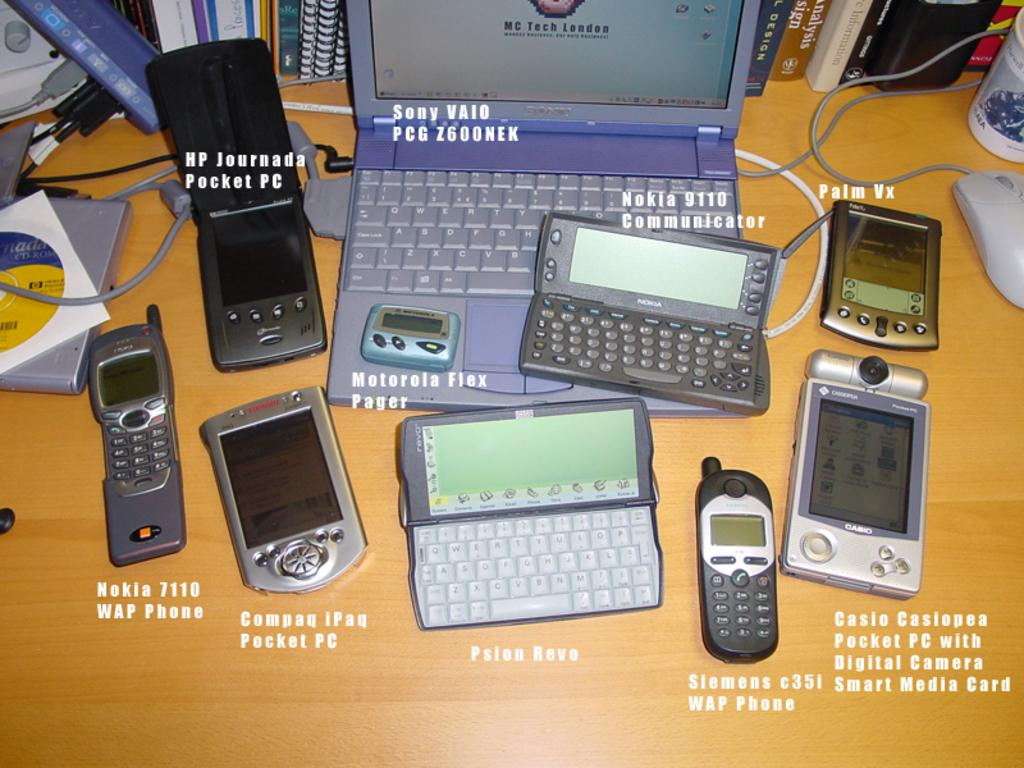<image>
Render a clear and concise summary of the photo. A Sony Vaio laptop sits on a desk with several cell phones around it. 